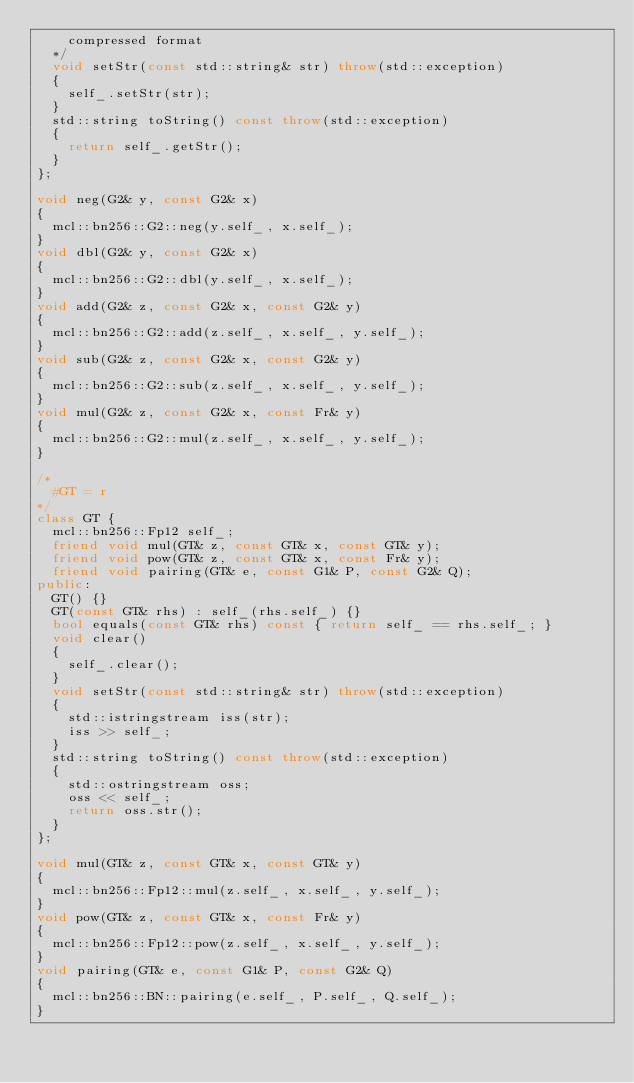Convert code to text. <code><loc_0><loc_0><loc_500><loc_500><_C++_>		compressed format
	*/
	void setStr(const std::string& str) throw(std::exception)
	{
		self_.setStr(str);
	}
	std::string toString() const throw(std::exception)
	{
		return self_.getStr();
	}
};

void neg(G2& y, const G2& x)
{
	mcl::bn256::G2::neg(y.self_, x.self_);
}
void dbl(G2& y, const G2& x)
{
	mcl::bn256::G2::dbl(y.self_, x.self_);
}
void add(G2& z, const G2& x, const G2& y)
{
	mcl::bn256::G2::add(z.self_, x.self_, y.self_);
}
void sub(G2& z, const G2& x, const G2& y)
{
	mcl::bn256::G2::sub(z.self_, x.self_, y.self_);
}
void mul(G2& z, const G2& x, const Fr& y)
{
	mcl::bn256::G2::mul(z.self_, x.self_, y.self_);
}

/*
	#GT = r
*/
class GT {
	mcl::bn256::Fp12 self_;
	friend void mul(GT& z, const GT& x, const GT& y);
	friend void pow(GT& z, const GT& x, const Fr& y);
	friend void pairing(GT& e, const G1& P, const G2& Q);
public:
	GT() {}
	GT(const GT& rhs) : self_(rhs.self_) {}
	bool equals(const GT& rhs) const { return self_ == rhs.self_; }
	void clear()
	{
		self_.clear();
	}
	void setStr(const std::string& str) throw(std::exception)
	{
		std::istringstream iss(str);
		iss >> self_;
	}
	std::string toString() const throw(std::exception)
	{
		std::ostringstream oss;
		oss << self_;
		return oss.str();
	}
};

void mul(GT& z, const GT& x, const GT& y)
{
	mcl::bn256::Fp12::mul(z.self_, x.self_, y.self_);
}
void pow(GT& z, const GT& x, const Fr& y)
{
	mcl::bn256::Fp12::pow(z.self_, x.self_, y.self_);
}
void pairing(GT& e, const G1& P, const G2& Q)
{
	mcl::bn256::BN::pairing(e.self_, P.self_, Q.self_);
}
</code> 